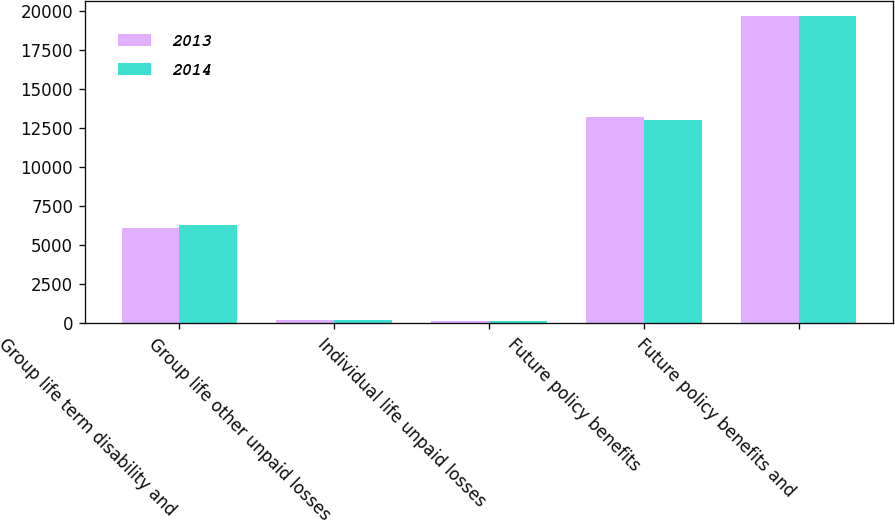Convert chart to OTSL. <chart><loc_0><loc_0><loc_500><loc_500><stacked_bar_chart><ecel><fcel>Group life term disability and<fcel>Group life other unpaid losses<fcel>Individual life unpaid losses<fcel>Future policy benefits<fcel>Future policy benefits and<nl><fcel>2013<fcel>6084<fcel>203<fcel>171<fcel>13180<fcel>19638<nl><fcel>2014<fcel>6308<fcel>206<fcel>167<fcel>12988<fcel>19669<nl></chart> 